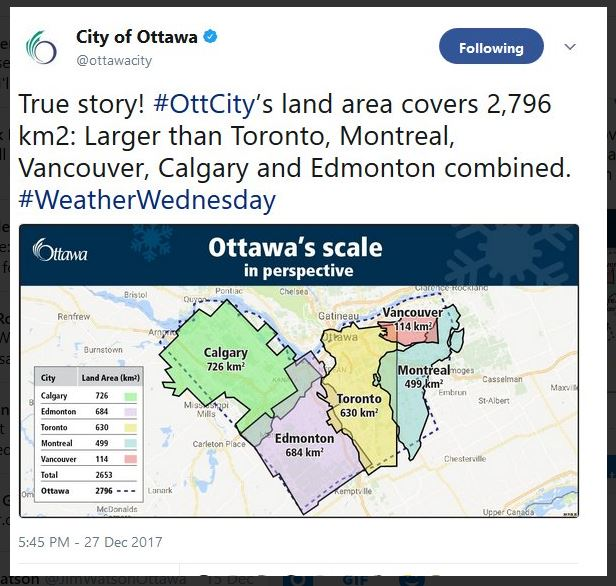Considering the land areas given for the individual cities and Ottawa itself, can you calculate and confirm if the statement that Ottawa's land area is indeed larger than the combined land areas of the other five cities is accurate? Based on the land areas provided for Calgary (726 km²), Edmonton (684 km²), Toronto (630 km²), Montreal (499 km²), and Vancouver (114 km²), we can calculate their combined land area: 726 + 684 + 630 + 499 + 114 = 2,653 square kilometers. Since Ottawa's land area is listed as 2,796 square kilometers, it is indeed larger than the combined land areas of these five cities by 143 square kilometers. Therefore, the statement is accurate. 